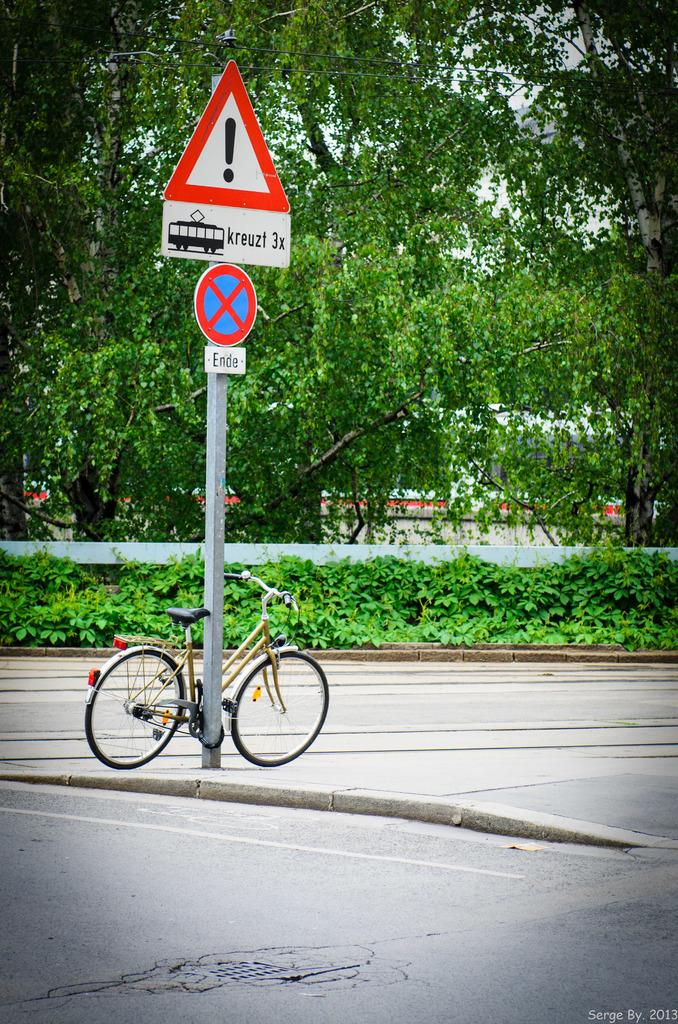<image>
Offer a succinct explanation of the picture presented. A bicycle is locked onto a pole with Ende and kruezl 3x on it on the street. 